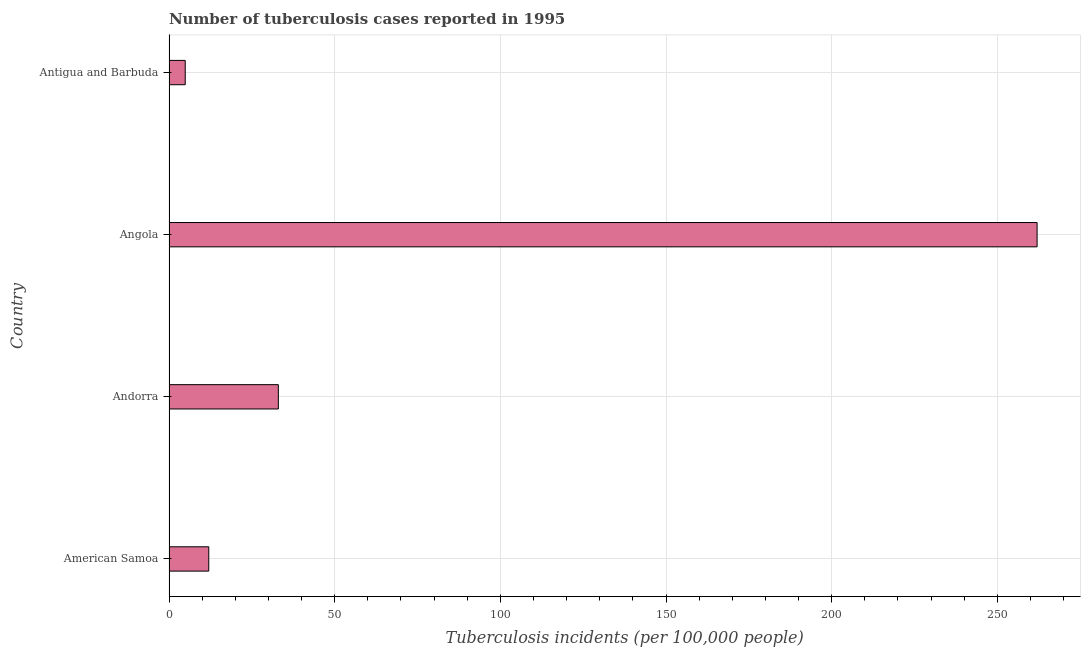Does the graph contain any zero values?
Your answer should be compact. No. What is the title of the graph?
Make the answer very short. Number of tuberculosis cases reported in 1995. What is the label or title of the X-axis?
Your response must be concise. Tuberculosis incidents (per 100,0 people). What is the label or title of the Y-axis?
Your response must be concise. Country. Across all countries, what is the maximum number of tuberculosis incidents?
Your answer should be compact. 262. Across all countries, what is the minimum number of tuberculosis incidents?
Offer a very short reply. 4.9. In which country was the number of tuberculosis incidents maximum?
Offer a terse response. Angola. In which country was the number of tuberculosis incidents minimum?
Make the answer very short. Antigua and Barbuda. What is the sum of the number of tuberculosis incidents?
Ensure brevity in your answer.  311.9. What is the average number of tuberculosis incidents per country?
Provide a short and direct response. 77.97. In how many countries, is the number of tuberculosis incidents greater than 230 ?
Offer a terse response. 1. What is the ratio of the number of tuberculosis incidents in Andorra to that in Antigua and Barbuda?
Ensure brevity in your answer.  6.74. What is the difference between the highest and the second highest number of tuberculosis incidents?
Your answer should be compact. 229. What is the difference between the highest and the lowest number of tuberculosis incidents?
Your response must be concise. 257.1. In how many countries, is the number of tuberculosis incidents greater than the average number of tuberculosis incidents taken over all countries?
Offer a very short reply. 1. What is the Tuberculosis incidents (per 100,000 people) of American Samoa?
Provide a short and direct response. 12. What is the Tuberculosis incidents (per 100,000 people) of Angola?
Make the answer very short. 262. What is the Tuberculosis incidents (per 100,000 people) of Antigua and Barbuda?
Ensure brevity in your answer.  4.9. What is the difference between the Tuberculosis incidents (per 100,000 people) in American Samoa and Andorra?
Make the answer very short. -21. What is the difference between the Tuberculosis incidents (per 100,000 people) in American Samoa and Angola?
Provide a short and direct response. -250. What is the difference between the Tuberculosis incidents (per 100,000 people) in American Samoa and Antigua and Barbuda?
Keep it short and to the point. 7.1. What is the difference between the Tuberculosis incidents (per 100,000 people) in Andorra and Angola?
Ensure brevity in your answer.  -229. What is the difference between the Tuberculosis incidents (per 100,000 people) in Andorra and Antigua and Barbuda?
Provide a short and direct response. 28.1. What is the difference between the Tuberculosis incidents (per 100,000 people) in Angola and Antigua and Barbuda?
Keep it short and to the point. 257.1. What is the ratio of the Tuberculosis incidents (per 100,000 people) in American Samoa to that in Andorra?
Your answer should be very brief. 0.36. What is the ratio of the Tuberculosis incidents (per 100,000 people) in American Samoa to that in Angola?
Provide a succinct answer. 0.05. What is the ratio of the Tuberculosis incidents (per 100,000 people) in American Samoa to that in Antigua and Barbuda?
Make the answer very short. 2.45. What is the ratio of the Tuberculosis incidents (per 100,000 people) in Andorra to that in Angola?
Offer a very short reply. 0.13. What is the ratio of the Tuberculosis incidents (per 100,000 people) in Andorra to that in Antigua and Barbuda?
Provide a short and direct response. 6.74. What is the ratio of the Tuberculosis incidents (per 100,000 people) in Angola to that in Antigua and Barbuda?
Offer a terse response. 53.47. 